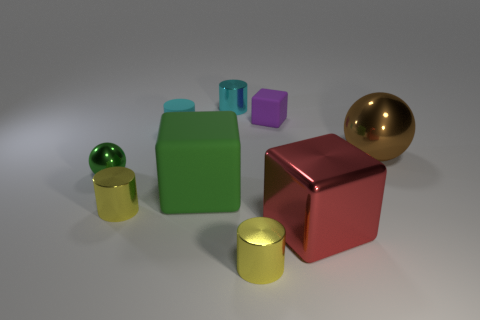Does the sphere on the left side of the big rubber object have the same color as the large matte cube?
Offer a terse response. Yes. Does the sphere that is behind the small green metal object have the same material as the cyan cylinder that is on the left side of the green matte thing?
Give a very brief answer. No. Do the metallic ball in front of the brown sphere and the large green cube have the same size?
Your answer should be compact. No. Is the color of the big shiny sphere the same as the rubber thing behind the tiny cyan matte object?
Provide a succinct answer. No. The metallic object that is the same color as the big rubber block is what shape?
Provide a short and direct response. Sphere. There is a large brown object; what shape is it?
Provide a short and direct response. Sphere. Is the tiny rubber cylinder the same color as the big metallic cube?
Your response must be concise. No. What number of objects are either yellow cylinders in front of the shiny block or tiny objects?
Keep it short and to the point. 6. What size is the brown sphere that is the same material as the large red object?
Keep it short and to the point. Large. Are there more small green balls that are left of the green shiny sphere than big shiny balls?
Provide a succinct answer. No. 